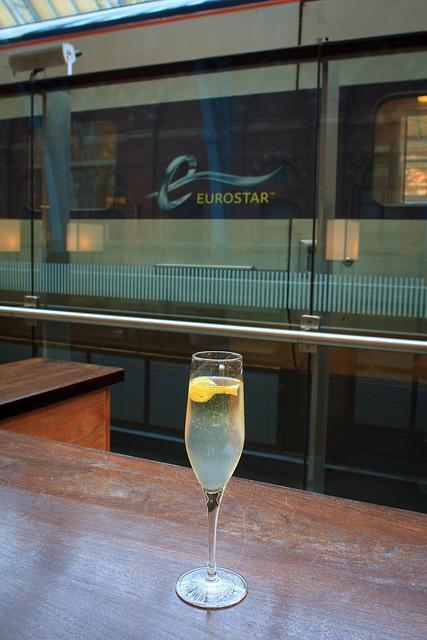How many glasses are there?
Give a very brief answer. 1. 